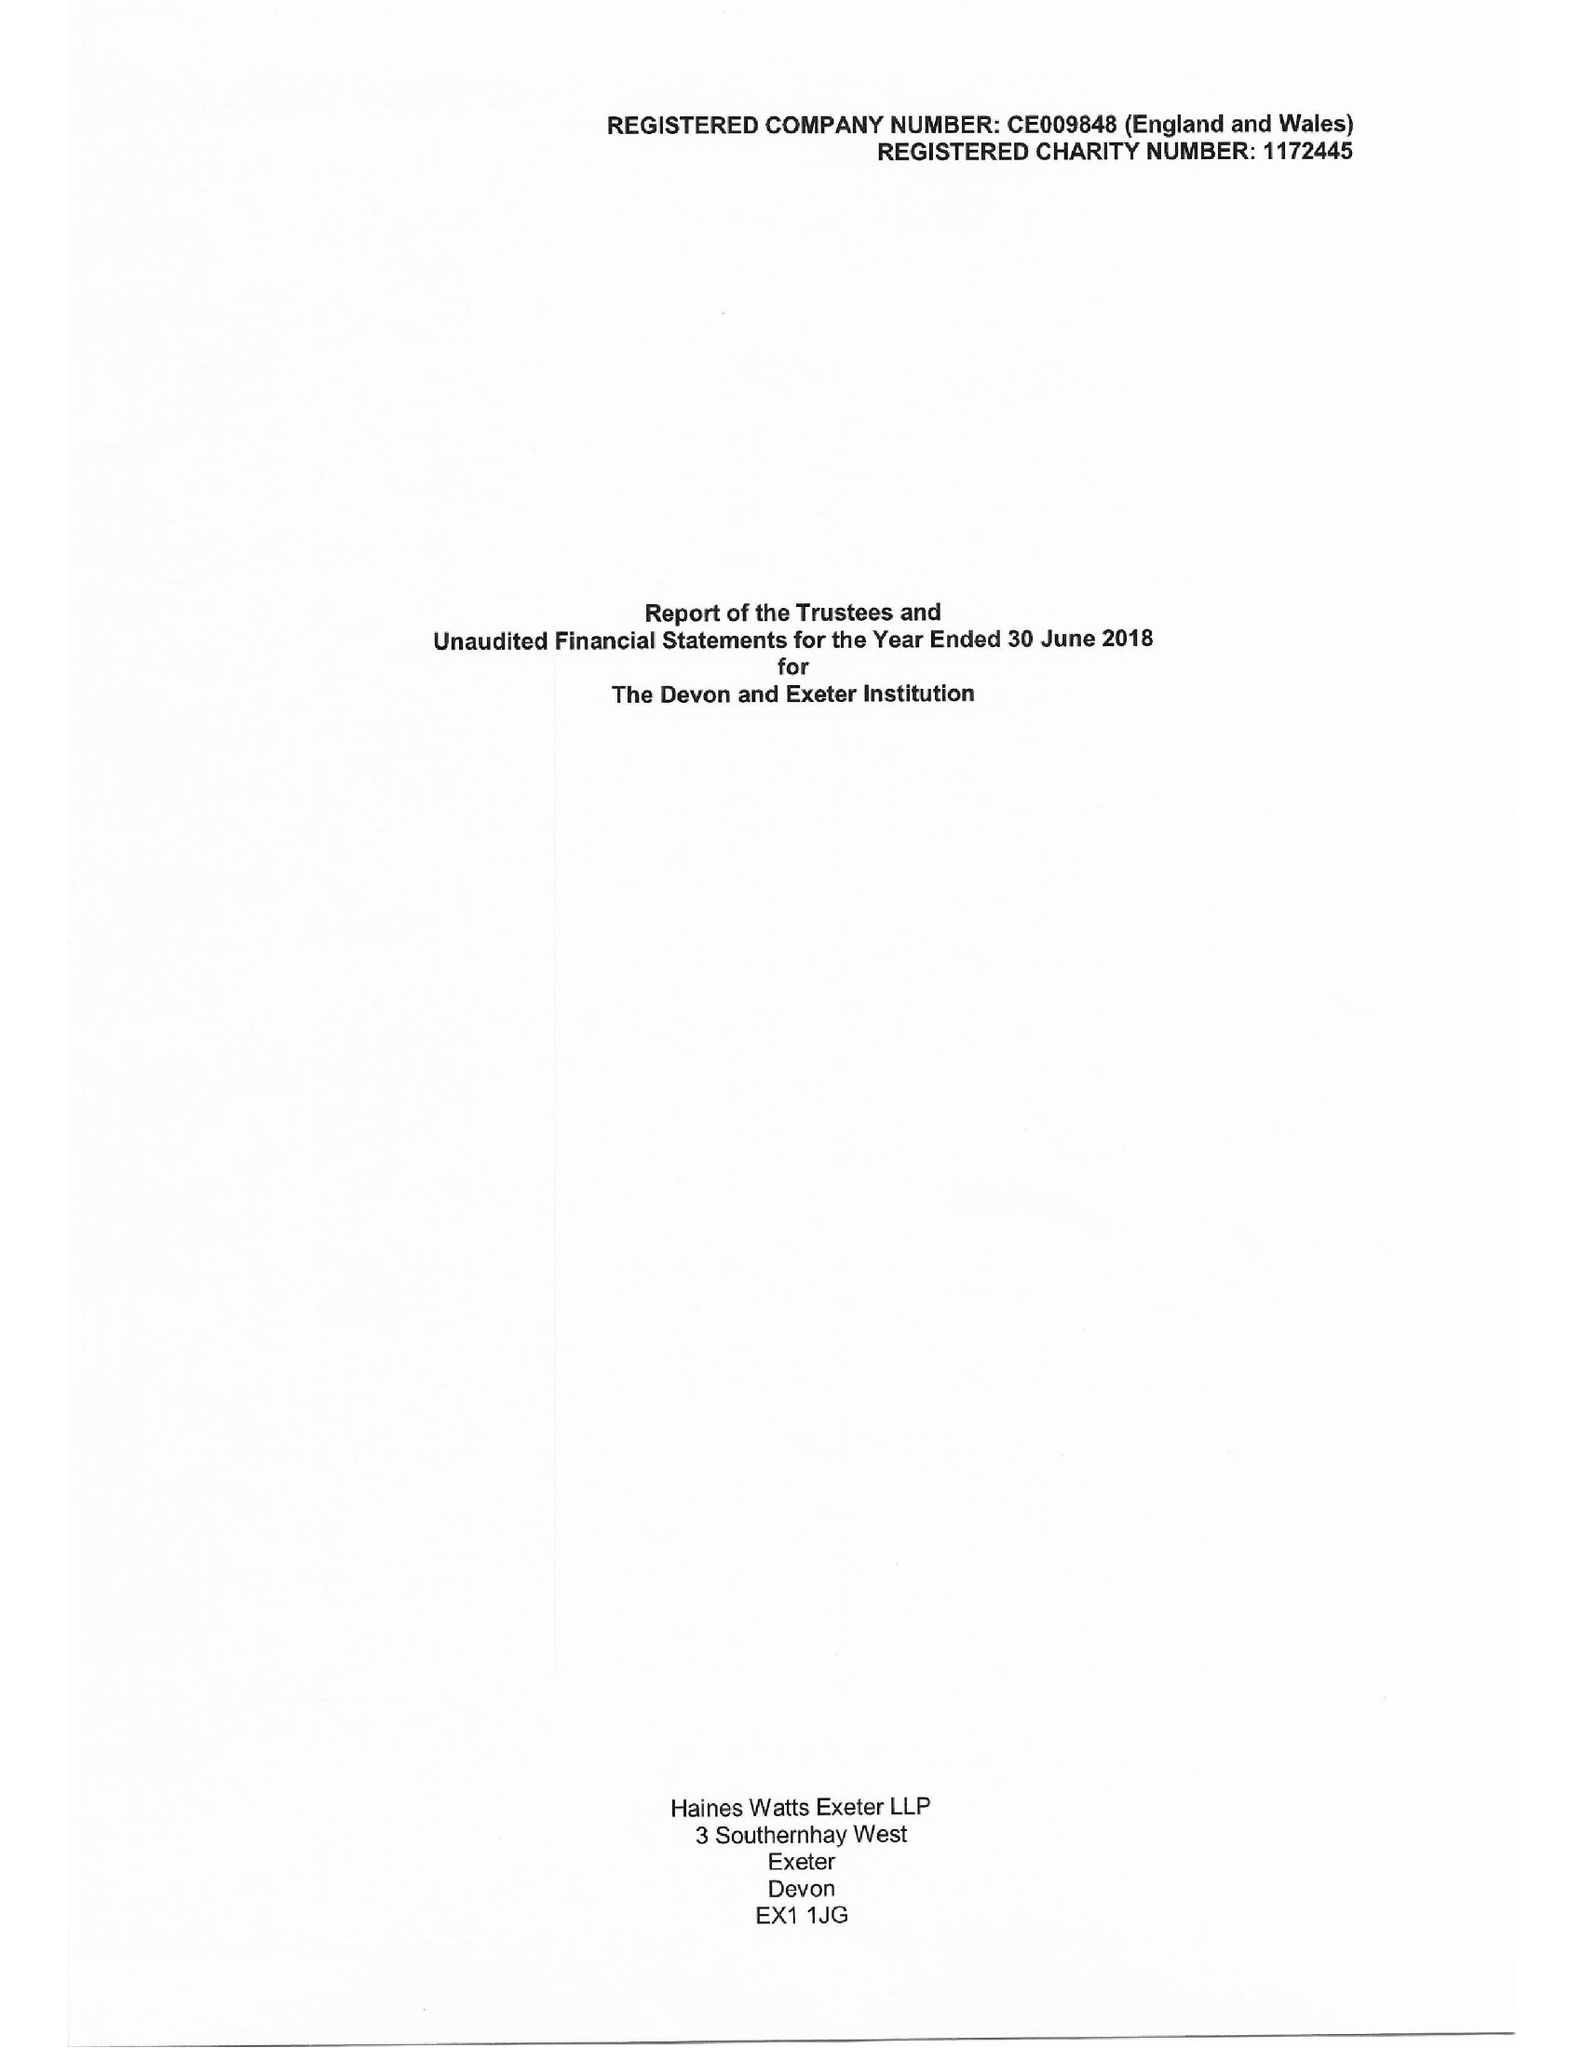What is the value for the income_annually_in_british_pounds?
Answer the question using a single word or phrase. 104537.00 